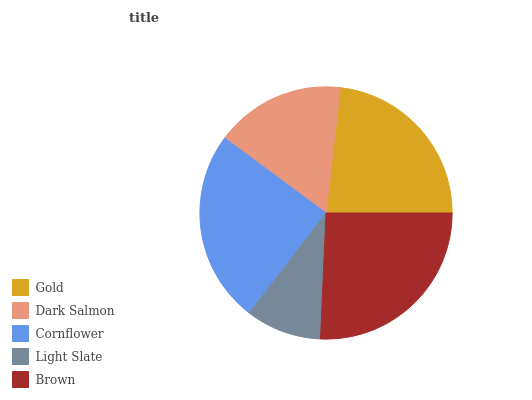Is Light Slate the minimum?
Answer yes or no. Yes. Is Brown the maximum?
Answer yes or no. Yes. Is Dark Salmon the minimum?
Answer yes or no. No. Is Dark Salmon the maximum?
Answer yes or no. No. Is Gold greater than Dark Salmon?
Answer yes or no. Yes. Is Dark Salmon less than Gold?
Answer yes or no. Yes. Is Dark Salmon greater than Gold?
Answer yes or no. No. Is Gold less than Dark Salmon?
Answer yes or no. No. Is Gold the high median?
Answer yes or no. Yes. Is Gold the low median?
Answer yes or no. Yes. Is Cornflower the high median?
Answer yes or no. No. Is Brown the low median?
Answer yes or no. No. 